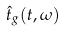Convert formula to latex. <formula><loc_0><loc_0><loc_500><loc_500>\hat { t } _ { g } ( t , \omega )</formula> 